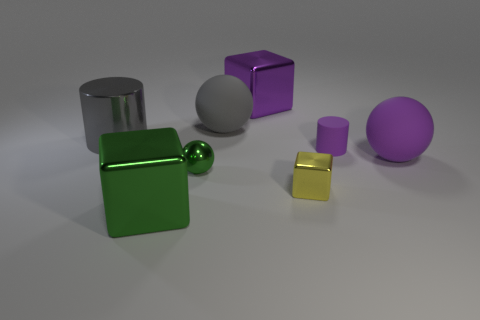What is the size of the cylinder left of the big purple thing behind the cylinder that is to the left of the green cube?
Your answer should be very brief. Large. Is the shape of the large purple rubber thing the same as the tiny yellow shiny thing that is on the right side of the purple shiny cube?
Keep it short and to the point. No. What size is the yellow object that is made of the same material as the tiny green sphere?
Your answer should be very brief. Small. Is there any other thing of the same color as the tiny cylinder?
Offer a terse response. Yes. What is the material of the cylinder that is on the right side of the large rubber object that is behind the large sphere that is in front of the gray metal thing?
Offer a very short reply. Rubber. How many rubber objects are green cubes or small yellow cubes?
Make the answer very short. 0. Do the shiny cylinder and the tiny shiny sphere have the same color?
Your answer should be compact. No. Is there anything else that has the same material as the tiny green thing?
Provide a short and direct response. Yes. What number of things are large purple objects or spheres on the left side of the large purple matte sphere?
Offer a very short reply. 4. There is a metal cube that is behind the green metal sphere; is its size the same as the large gray ball?
Your answer should be very brief. Yes. 